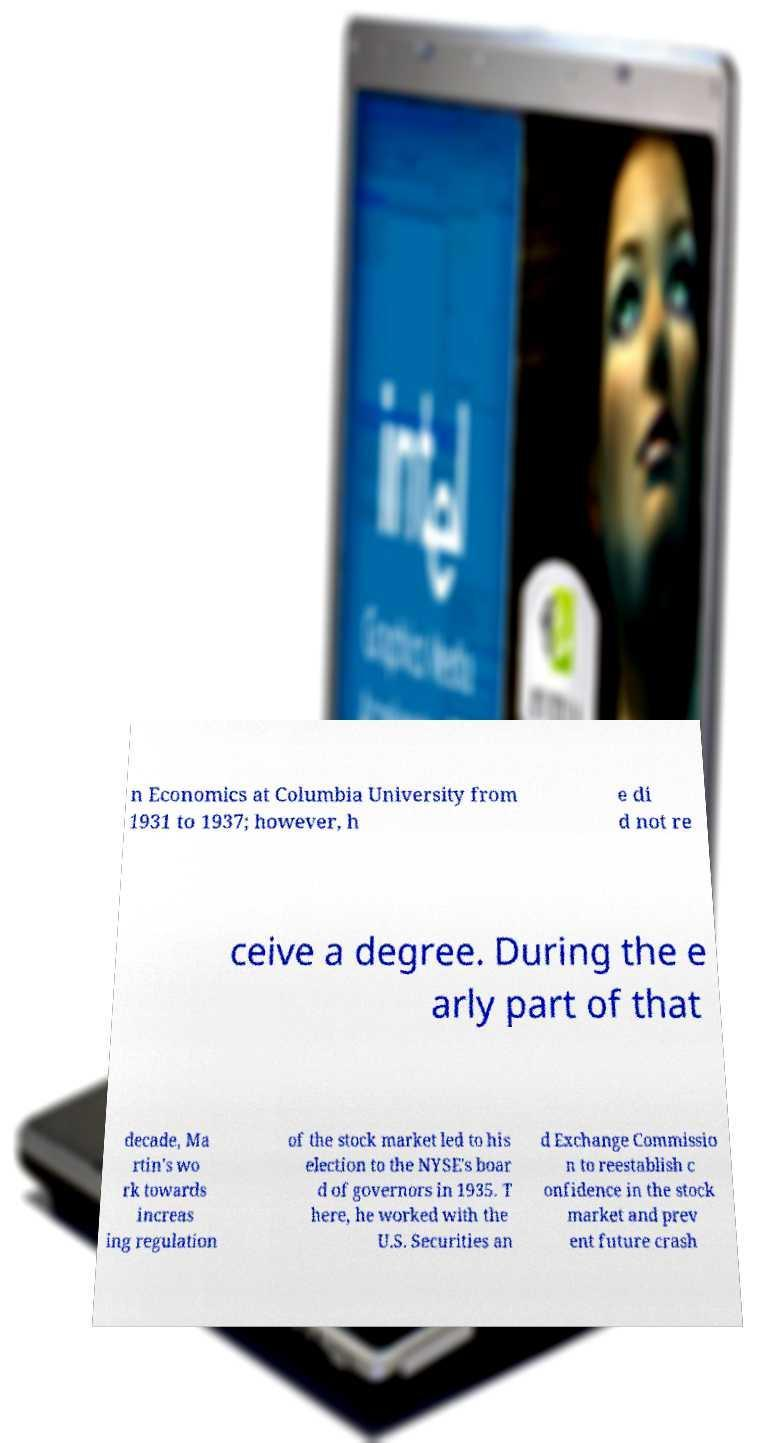Please identify and transcribe the text found in this image. n Economics at Columbia University from 1931 to 1937; however, h e di d not re ceive a degree. During the e arly part of that decade, Ma rtin's wo rk towards increas ing regulation of the stock market led to his election to the NYSE's boar d of governors in 1935. T here, he worked with the U.S. Securities an d Exchange Commissio n to reestablish c onfidence in the stock market and prev ent future crash 